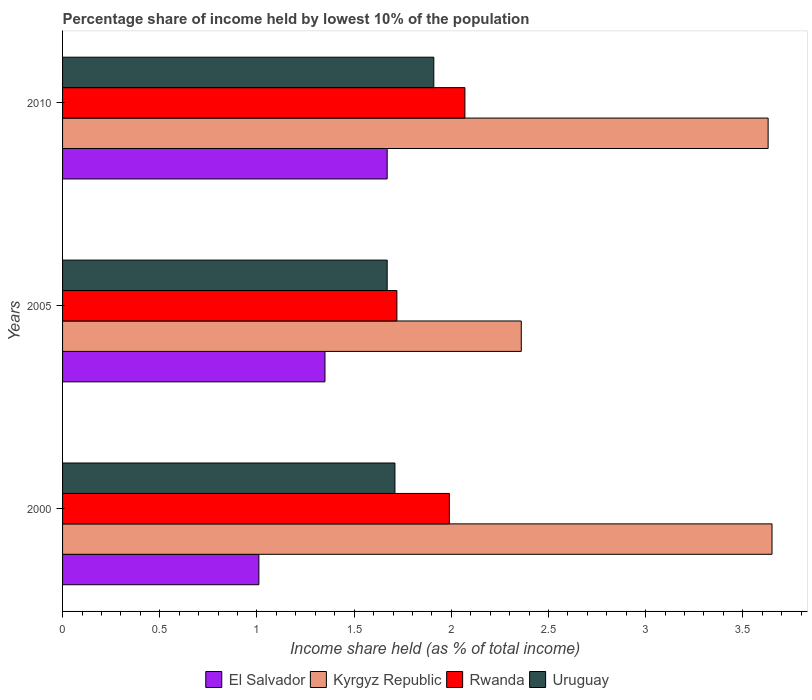How many groups of bars are there?
Your answer should be very brief. 3. Are the number of bars per tick equal to the number of legend labels?
Offer a terse response. Yes. Are the number of bars on each tick of the Y-axis equal?
Give a very brief answer. Yes. How many bars are there on the 3rd tick from the top?
Your answer should be compact. 4. What is the percentage share of income held by lowest 10% of the population in Uruguay in 2000?
Ensure brevity in your answer.  1.71. Across all years, what is the maximum percentage share of income held by lowest 10% of the population in El Salvador?
Provide a short and direct response. 1.67. Across all years, what is the minimum percentage share of income held by lowest 10% of the population in Kyrgyz Republic?
Provide a succinct answer. 2.36. In which year was the percentage share of income held by lowest 10% of the population in Uruguay maximum?
Offer a very short reply. 2010. What is the total percentage share of income held by lowest 10% of the population in Rwanda in the graph?
Offer a terse response. 5.78. What is the difference between the percentage share of income held by lowest 10% of the population in Kyrgyz Republic in 2005 and that in 2010?
Give a very brief answer. -1.27. What is the difference between the percentage share of income held by lowest 10% of the population in El Salvador in 2005 and the percentage share of income held by lowest 10% of the population in Kyrgyz Republic in 2000?
Your answer should be compact. -2.3. What is the average percentage share of income held by lowest 10% of the population in Rwanda per year?
Offer a very short reply. 1.93. In the year 2005, what is the difference between the percentage share of income held by lowest 10% of the population in Uruguay and percentage share of income held by lowest 10% of the population in El Salvador?
Ensure brevity in your answer.  0.32. What is the ratio of the percentage share of income held by lowest 10% of the population in Rwanda in 2000 to that in 2010?
Provide a short and direct response. 0.96. Is the percentage share of income held by lowest 10% of the population in Rwanda in 2000 less than that in 2010?
Your answer should be compact. Yes. What is the difference between the highest and the second highest percentage share of income held by lowest 10% of the population in Uruguay?
Offer a very short reply. 0.2. What is the difference between the highest and the lowest percentage share of income held by lowest 10% of the population in Rwanda?
Provide a succinct answer. 0.35. Is the sum of the percentage share of income held by lowest 10% of the population in Uruguay in 2005 and 2010 greater than the maximum percentage share of income held by lowest 10% of the population in El Salvador across all years?
Your response must be concise. Yes. What does the 4th bar from the top in 2000 represents?
Offer a terse response. El Salvador. What does the 3rd bar from the bottom in 2005 represents?
Your answer should be compact. Rwanda. How many bars are there?
Offer a very short reply. 12. How many years are there in the graph?
Provide a short and direct response. 3. Does the graph contain any zero values?
Make the answer very short. No. How are the legend labels stacked?
Provide a short and direct response. Horizontal. What is the title of the graph?
Your answer should be compact. Percentage share of income held by lowest 10% of the population. What is the label or title of the X-axis?
Your answer should be very brief. Income share held (as % of total income). What is the label or title of the Y-axis?
Ensure brevity in your answer.  Years. What is the Income share held (as % of total income) of El Salvador in 2000?
Your answer should be compact. 1.01. What is the Income share held (as % of total income) of Kyrgyz Republic in 2000?
Your answer should be very brief. 3.65. What is the Income share held (as % of total income) in Rwanda in 2000?
Your answer should be compact. 1.99. What is the Income share held (as % of total income) in Uruguay in 2000?
Give a very brief answer. 1.71. What is the Income share held (as % of total income) in El Salvador in 2005?
Provide a short and direct response. 1.35. What is the Income share held (as % of total income) in Kyrgyz Republic in 2005?
Offer a terse response. 2.36. What is the Income share held (as % of total income) in Rwanda in 2005?
Your answer should be very brief. 1.72. What is the Income share held (as % of total income) of Uruguay in 2005?
Keep it short and to the point. 1.67. What is the Income share held (as % of total income) of El Salvador in 2010?
Make the answer very short. 1.67. What is the Income share held (as % of total income) of Kyrgyz Republic in 2010?
Your answer should be very brief. 3.63. What is the Income share held (as % of total income) in Rwanda in 2010?
Offer a very short reply. 2.07. What is the Income share held (as % of total income) of Uruguay in 2010?
Ensure brevity in your answer.  1.91. Across all years, what is the maximum Income share held (as % of total income) of El Salvador?
Provide a short and direct response. 1.67. Across all years, what is the maximum Income share held (as % of total income) in Kyrgyz Republic?
Keep it short and to the point. 3.65. Across all years, what is the maximum Income share held (as % of total income) of Rwanda?
Provide a succinct answer. 2.07. Across all years, what is the maximum Income share held (as % of total income) of Uruguay?
Provide a short and direct response. 1.91. Across all years, what is the minimum Income share held (as % of total income) of El Salvador?
Your response must be concise. 1.01. Across all years, what is the minimum Income share held (as % of total income) in Kyrgyz Republic?
Provide a short and direct response. 2.36. Across all years, what is the minimum Income share held (as % of total income) in Rwanda?
Offer a terse response. 1.72. Across all years, what is the minimum Income share held (as % of total income) of Uruguay?
Keep it short and to the point. 1.67. What is the total Income share held (as % of total income) in El Salvador in the graph?
Offer a very short reply. 4.03. What is the total Income share held (as % of total income) of Kyrgyz Republic in the graph?
Offer a very short reply. 9.64. What is the total Income share held (as % of total income) of Rwanda in the graph?
Your answer should be compact. 5.78. What is the total Income share held (as % of total income) of Uruguay in the graph?
Your answer should be compact. 5.29. What is the difference between the Income share held (as % of total income) in El Salvador in 2000 and that in 2005?
Provide a succinct answer. -0.34. What is the difference between the Income share held (as % of total income) of Kyrgyz Republic in 2000 and that in 2005?
Keep it short and to the point. 1.29. What is the difference between the Income share held (as % of total income) in Rwanda in 2000 and that in 2005?
Offer a very short reply. 0.27. What is the difference between the Income share held (as % of total income) in Uruguay in 2000 and that in 2005?
Provide a short and direct response. 0.04. What is the difference between the Income share held (as % of total income) in El Salvador in 2000 and that in 2010?
Offer a terse response. -0.66. What is the difference between the Income share held (as % of total income) in Kyrgyz Republic in 2000 and that in 2010?
Your answer should be very brief. 0.02. What is the difference between the Income share held (as % of total income) in Rwanda in 2000 and that in 2010?
Make the answer very short. -0.08. What is the difference between the Income share held (as % of total income) in El Salvador in 2005 and that in 2010?
Keep it short and to the point. -0.32. What is the difference between the Income share held (as % of total income) of Kyrgyz Republic in 2005 and that in 2010?
Keep it short and to the point. -1.27. What is the difference between the Income share held (as % of total income) in Rwanda in 2005 and that in 2010?
Make the answer very short. -0.35. What is the difference between the Income share held (as % of total income) of Uruguay in 2005 and that in 2010?
Ensure brevity in your answer.  -0.24. What is the difference between the Income share held (as % of total income) of El Salvador in 2000 and the Income share held (as % of total income) of Kyrgyz Republic in 2005?
Your answer should be compact. -1.35. What is the difference between the Income share held (as % of total income) in El Salvador in 2000 and the Income share held (as % of total income) in Rwanda in 2005?
Make the answer very short. -0.71. What is the difference between the Income share held (as % of total income) in El Salvador in 2000 and the Income share held (as % of total income) in Uruguay in 2005?
Ensure brevity in your answer.  -0.66. What is the difference between the Income share held (as % of total income) in Kyrgyz Republic in 2000 and the Income share held (as % of total income) in Rwanda in 2005?
Offer a very short reply. 1.93. What is the difference between the Income share held (as % of total income) in Kyrgyz Republic in 2000 and the Income share held (as % of total income) in Uruguay in 2005?
Your answer should be very brief. 1.98. What is the difference between the Income share held (as % of total income) of Rwanda in 2000 and the Income share held (as % of total income) of Uruguay in 2005?
Your answer should be very brief. 0.32. What is the difference between the Income share held (as % of total income) in El Salvador in 2000 and the Income share held (as % of total income) in Kyrgyz Republic in 2010?
Your answer should be compact. -2.62. What is the difference between the Income share held (as % of total income) in El Salvador in 2000 and the Income share held (as % of total income) in Rwanda in 2010?
Provide a short and direct response. -1.06. What is the difference between the Income share held (as % of total income) in Kyrgyz Republic in 2000 and the Income share held (as % of total income) in Rwanda in 2010?
Offer a very short reply. 1.58. What is the difference between the Income share held (as % of total income) of Kyrgyz Republic in 2000 and the Income share held (as % of total income) of Uruguay in 2010?
Give a very brief answer. 1.74. What is the difference between the Income share held (as % of total income) of Rwanda in 2000 and the Income share held (as % of total income) of Uruguay in 2010?
Your answer should be compact. 0.08. What is the difference between the Income share held (as % of total income) of El Salvador in 2005 and the Income share held (as % of total income) of Kyrgyz Republic in 2010?
Provide a succinct answer. -2.28. What is the difference between the Income share held (as % of total income) in El Salvador in 2005 and the Income share held (as % of total income) in Rwanda in 2010?
Your response must be concise. -0.72. What is the difference between the Income share held (as % of total income) in El Salvador in 2005 and the Income share held (as % of total income) in Uruguay in 2010?
Make the answer very short. -0.56. What is the difference between the Income share held (as % of total income) in Kyrgyz Republic in 2005 and the Income share held (as % of total income) in Rwanda in 2010?
Provide a short and direct response. 0.29. What is the difference between the Income share held (as % of total income) in Kyrgyz Republic in 2005 and the Income share held (as % of total income) in Uruguay in 2010?
Offer a terse response. 0.45. What is the difference between the Income share held (as % of total income) of Rwanda in 2005 and the Income share held (as % of total income) of Uruguay in 2010?
Your response must be concise. -0.19. What is the average Income share held (as % of total income) of El Salvador per year?
Offer a terse response. 1.34. What is the average Income share held (as % of total income) in Kyrgyz Republic per year?
Make the answer very short. 3.21. What is the average Income share held (as % of total income) in Rwanda per year?
Provide a short and direct response. 1.93. What is the average Income share held (as % of total income) in Uruguay per year?
Your answer should be compact. 1.76. In the year 2000, what is the difference between the Income share held (as % of total income) in El Salvador and Income share held (as % of total income) in Kyrgyz Republic?
Keep it short and to the point. -2.64. In the year 2000, what is the difference between the Income share held (as % of total income) of El Salvador and Income share held (as % of total income) of Rwanda?
Make the answer very short. -0.98. In the year 2000, what is the difference between the Income share held (as % of total income) in El Salvador and Income share held (as % of total income) in Uruguay?
Make the answer very short. -0.7. In the year 2000, what is the difference between the Income share held (as % of total income) in Kyrgyz Republic and Income share held (as % of total income) in Rwanda?
Provide a short and direct response. 1.66. In the year 2000, what is the difference between the Income share held (as % of total income) of Kyrgyz Republic and Income share held (as % of total income) of Uruguay?
Provide a succinct answer. 1.94. In the year 2000, what is the difference between the Income share held (as % of total income) in Rwanda and Income share held (as % of total income) in Uruguay?
Offer a terse response. 0.28. In the year 2005, what is the difference between the Income share held (as % of total income) of El Salvador and Income share held (as % of total income) of Kyrgyz Republic?
Give a very brief answer. -1.01. In the year 2005, what is the difference between the Income share held (as % of total income) in El Salvador and Income share held (as % of total income) in Rwanda?
Offer a terse response. -0.37. In the year 2005, what is the difference between the Income share held (as % of total income) in El Salvador and Income share held (as % of total income) in Uruguay?
Your answer should be very brief. -0.32. In the year 2005, what is the difference between the Income share held (as % of total income) of Kyrgyz Republic and Income share held (as % of total income) of Rwanda?
Offer a very short reply. 0.64. In the year 2005, what is the difference between the Income share held (as % of total income) of Kyrgyz Republic and Income share held (as % of total income) of Uruguay?
Give a very brief answer. 0.69. In the year 2005, what is the difference between the Income share held (as % of total income) in Rwanda and Income share held (as % of total income) in Uruguay?
Provide a succinct answer. 0.05. In the year 2010, what is the difference between the Income share held (as % of total income) in El Salvador and Income share held (as % of total income) in Kyrgyz Republic?
Provide a succinct answer. -1.96. In the year 2010, what is the difference between the Income share held (as % of total income) of El Salvador and Income share held (as % of total income) of Uruguay?
Provide a succinct answer. -0.24. In the year 2010, what is the difference between the Income share held (as % of total income) of Kyrgyz Republic and Income share held (as % of total income) of Rwanda?
Give a very brief answer. 1.56. In the year 2010, what is the difference between the Income share held (as % of total income) in Kyrgyz Republic and Income share held (as % of total income) in Uruguay?
Offer a terse response. 1.72. In the year 2010, what is the difference between the Income share held (as % of total income) in Rwanda and Income share held (as % of total income) in Uruguay?
Your answer should be compact. 0.16. What is the ratio of the Income share held (as % of total income) in El Salvador in 2000 to that in 2005?
Give a very brief answer. 0.75. What is the ratio of the Income share held (as % of total income) of Kyrgyz Republic in 2000 to that in 2005?
Give a very brief answer. 1.55. What is the ratio of the Income share held (as % of total income) in Rwanda in 2000 to that in 2005?
Keep it short and to the point. 1.16. What is the ratio of the Income share held (as % of total income) in El Salvador in 2000 to that in 2010?
Provide a short and direct response. 0.6. What is the ratio of the Income share held (as % of total income) in Rwanda in 2000 to that in 2010?
Keep it short and to the point. 0.96. What is the ratio of the Income share held (as % of total income) in Uruguay in 2000 to that in 2010?
Provide a succinct answer. 0.9. What is the ratio of the Income share held (as % of total income) of El Salvador in 2005 to that in 2010?
Your response must be concise. 0.81. What is the ratio of the Income share held (as % of total income) in Kyrgyz Republic in 2005 to that in 2010?
Make the answer very short. 0.65. What is the ratio of the Income share held (as % of total income) of Rwanda in 2005 to that in 2010?
Your answer should be very brief. 0.83. What is the ratio of the Income share held (as % of total income) in Uruguay in 2005 to that in 2010?
Offer a very short reply. 0.87. What is the difference between the highest and the second highest Income share held (as % of total income) of El Salvador?
Your answer should be compact. 0.32. What is the difference between the highest and the second highest Income share held (as % of total income) in Uruguay?
Provide a short and direct response. 0.2. What is the difference between the highest and the lowest Income share held (as % of total income) in El Salvador?
Keep it short and to the point. 0.66. What is the difference between the highest and the lowest Income share held (as % of total income) of Kyrgyz Republic?
Keep it short and to the point. 1.29. What is the difference between the highest and the lowest Income share held (as % of total income) in Rwanda?
Your answer should be compact. 0.35. What is the difference between the highest and the lowest Income share held (as % of total income) in Uruguay?
Provide a succinct answer. 0.24. 